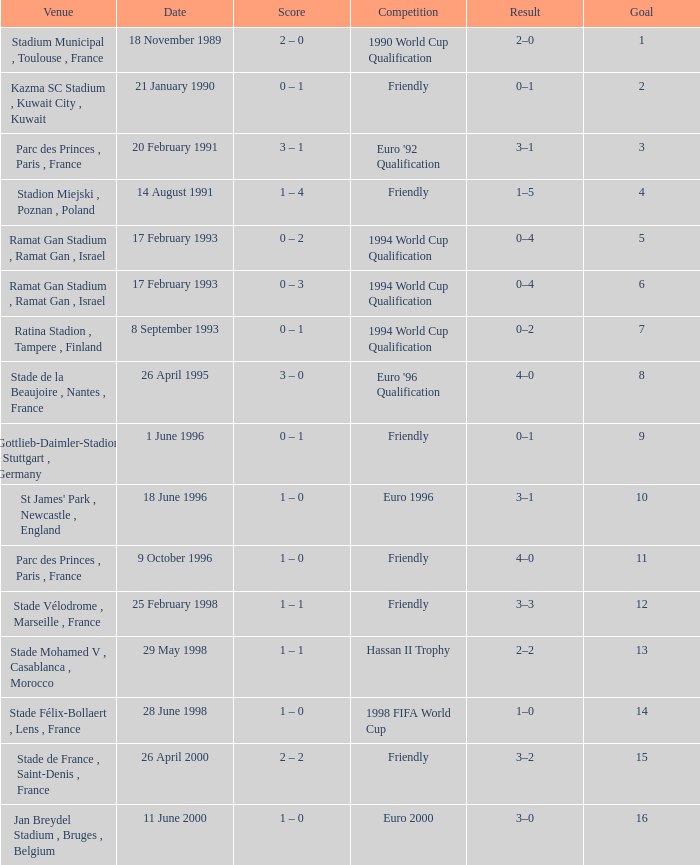What was the date of the game with a goal of 7? 8 September 1993. 